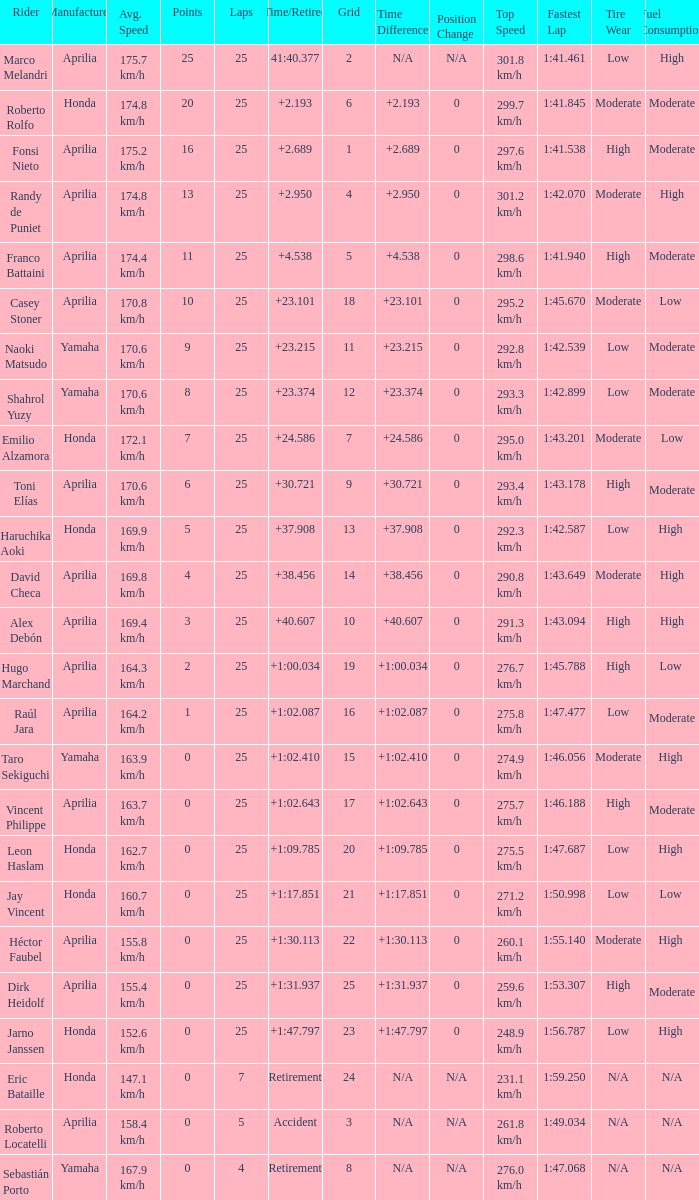Which Manufacturer has a Time/Retired of accident? Aprilia. 